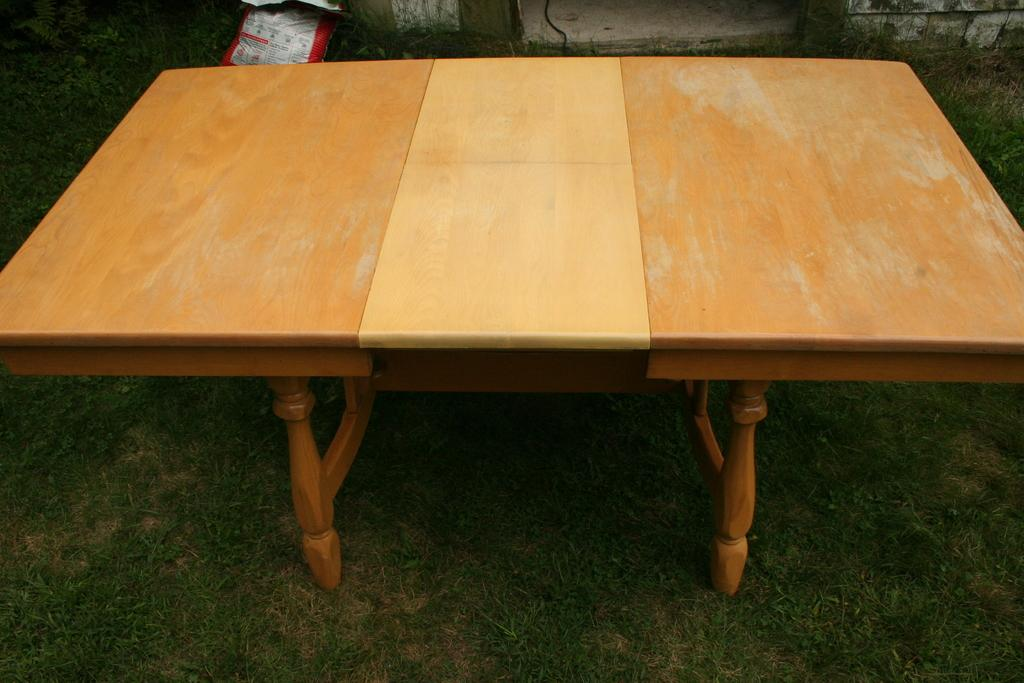What is the main object in the center of the image? There is a table in the center of the image. How is the table positioned in relation to the ground? The table is placed on the ground. What can be seen in the background of the image? There is a bag and grass in the background of the image. What type of skirt is hanging from the table in the image? There is no skirt hanging from the table in the image. How many bushes are visible in the background of the image? There is no mention of bushes in the image; only grass is visible in the background. 